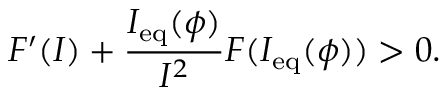<formula> <loc_0><loc_0><loc_500><loc_500>F ^ { \prime } ( I ) + \frac { I _ { e q } ( \phi ) } { I ^ { 2 } } F ( I _ { e q } ( \phi ) ) > 0 .</formula> 